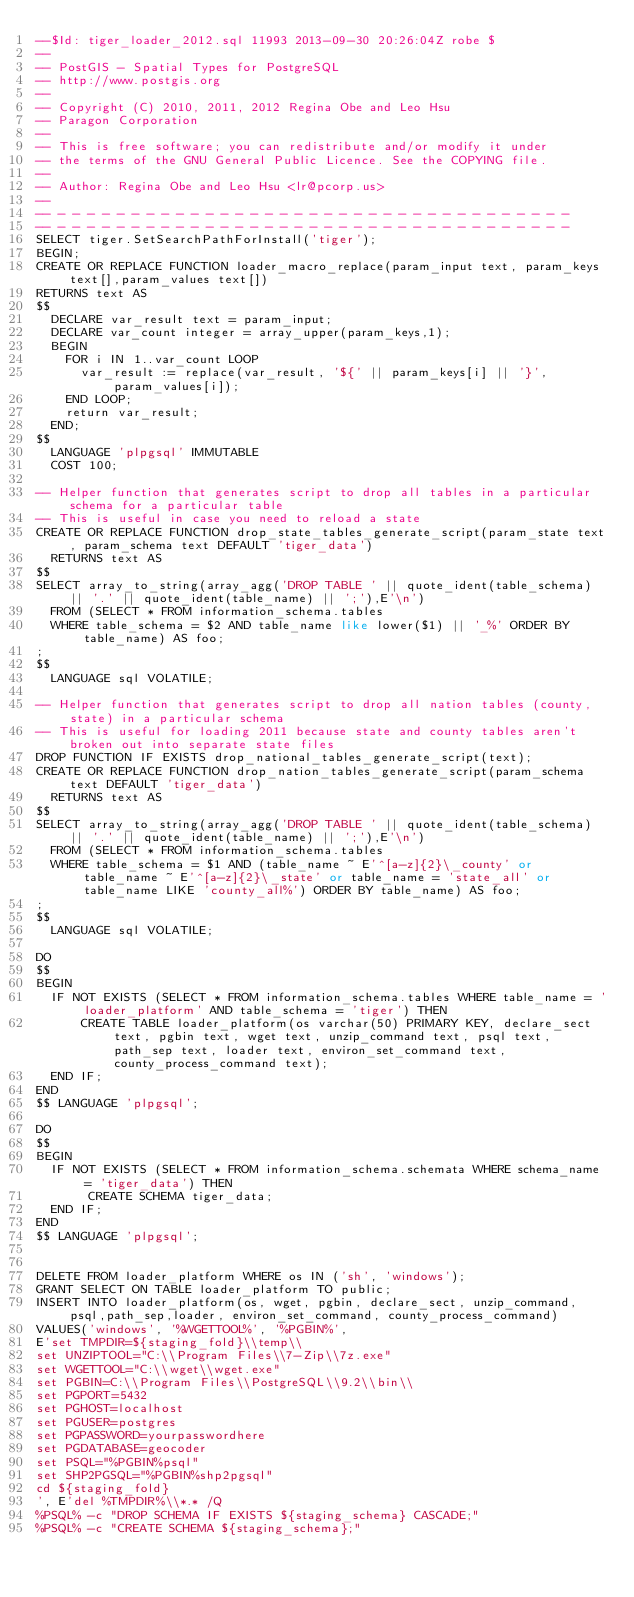Convert code to text. <code><loc_0><loc_0><loc_500><loc_500><_SQL_>--$Id: tiger_loader_2012.sql 11993 2013-09-30 20:26:04Z robe $
--
-- PostGIS - Spatial Types for PostgreSQL
-- http://www.postgis.org
--
-- Copyright (C) 2010, 2011, 2012 Regina Obe and Leo Hsu 
-- Paragon Corporation
--
-- This is free software; you can redistribute and/or modify it under
-- the terms of the GNU General Public Licence. See the COPYING file.
--
-- Author: Regina Obe and Leo Hsu <lr@pcorp.us>
--  
-- - - - - - - - - - - - - - - - - - - - - - - - - - - - - - - - - - - -
-- - - - - - - - - - - - - - - - - - - - - - - - - - - - - - - - - - - -
SELECT tiger.SetSearchPathForInstall('tiger');
BEGIN;
CREATE OR REPLACE FUNCTION loader_macro_replace(param_input text, param_keys text[],param_values text[]) 
RETURNS text AS
$$
	DECLARE var_result text = param_input;
	DECLARE var_count integer = array_upper(param_keys,1);
	BEGIN
		FOR i IN 1..var_count LOOP
			var_result := replace(var_result, '${' || param_keys[i] || '}', param_values[i]);
		END LOOP;
		return var_result;
	END;
$$
  LANGUAGE 'plpgsql' IMMUTABLE
  COST 100;

-- Helper function that generates script to drop all tables in a particular schema for a particular table
-- This is useful in case you need to reload a state
CREATE OR REPLACE FUNCTION drop_state_tables_generate_script(param_state text, param_schema text DEFAULT 'tiger_data')
  RETURNS text AS
$$
SELECT array_to_string(array_agg('DROP TABLE ' || quote_ident(table_schema) || '.' || quote_ident(table_name) || ';'),E'\n')
	FROM (SELECT * FROM information_schema.tables
	WHERE table_schema = $2 AND table_name like lower($1) || '_%' ORDER BY table_name) AS foo; 
;
$$
  LANGUAGE sql VOLATILE;
  
-- Helper function that generates script to drop all nation tables (county, state) in a particular schema 
-- This is useful for loading 2011 because state and county tables aren't broken out into separate state files
DROP FUNCTION IF EXISTS drop_national_tables_generate_script(text);
CREATE OR REPLACE FUNCTION drop_nation_tables_generate_script(param_schema text DEFAULT 'tiger_data')
  RETURNS text AS
$$
SELECT array_to_string(array_agg('DROP TABLE ' || quote_ident(table_schema) || '.' || quote_ident(table_name) || ';'),E'\n')
	FROM (SELECT * FROM information_schema.tables
	WHERE table_schema = $1 AND (table_name ~ E'^[a-z]{2}\_county' or table_name ~ E'^[a-z]{2}\_state' or table_name = 'state_all' or table_name LIKE 'county_all%') ORDER BY table_name) AS foo; 
;
$$
  LANGUAGE sql VOLATILE;
  
DO 
$$
BEGIN
  IF NOT EXISTS (SELECT * FROM information_schema.tables WHERE table_name = 'loader_platform' AND table_schema = 'tiger') THEN
      CREATE TABLE loader_platform(os varchar(50) PRIMARY KEY, declare_sect text, pgbin text, wget text, unzip_command text, psql text, path_sep text, loader text, environ_set_command text, county_process_command text);     
  END IF;   
END 
$$ LANGUAGE 'plpgsql';

DO 
$$
BEGIN
  IF NOT EXISTS (SELECT * FROM information_schema.schemata WHERE schema_name = 'tiger_data') THEN
       CREATE SCHEMA tiger_data;     
  END IF;   
END 
$$ LANGUAGE 'plpgsql';


DELETE FROM loader_platform WHERE os IN ('sh', 'windows');
GRANT SELECT ON TABLE loader_platform TO public;
INSERT INTO loader_platform(os, wget, pgbin, declare_sect, unzip_command, psql,path_sep,loader, environ_set_command, county_process_command)
VALUES('windows', '%WGETTOOL%', '%PGBIN%', 
E'set TMPDIR=${staging_fold}\\temp\\
set UNZIPTOOL="C:\\Program Files\\7-Zip\\7z.exe"
set WGETTOOL="C:\\wget\\wget.exe"
set PGBIN=C:\\Program Files\\PostgreSQL\\9.2\\bin\\
set PGPORT=5432
set PGHOST=localhost
set PGUSER=postgres
set PGPASSWORD=yourpasswordhere
set PGDATABASE=geocoder
set PSQL="%PGBIN%psql"
set SHP2PGSQL="%PGBIN%shp2pgsql"
cd ${staging_fold}
', E'del %TMPDIR%\\*.* /Q
%PSQL% -c "DROP SCHEMA IF EXISTS ${staging_schema} CASCADE;"
%PSQL% -c "CREATE SCHEMA ${staging_schema};"</code> 